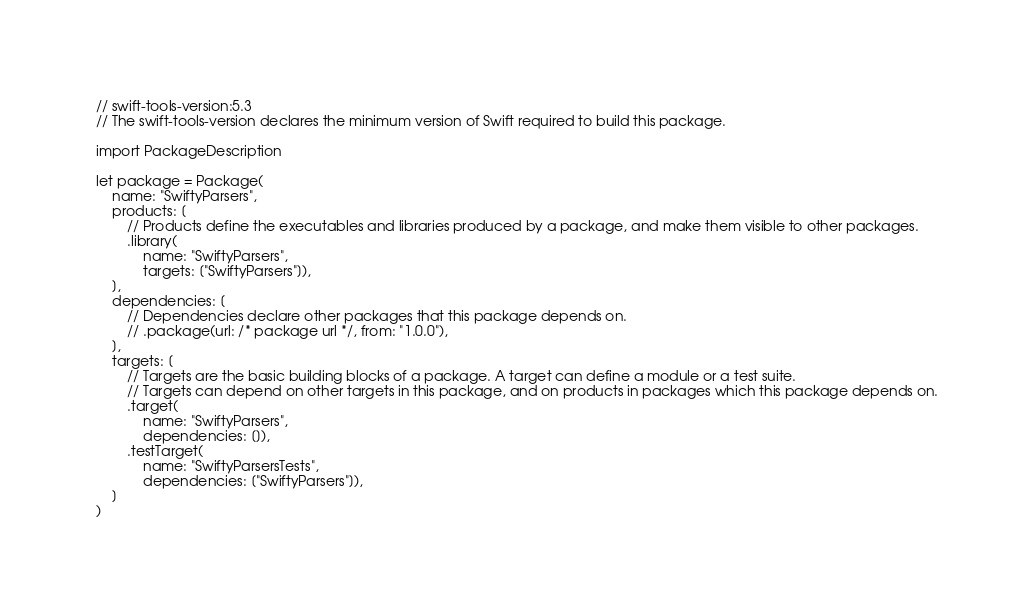<code> <loc_0><loc_0><loc_500><loc_500><_Swift_>// swift-tools-version:5.3
// The swift-tools-version declares the minimum version of Swift required to build this package.

import PackageDescription

let package = Package(
    name: "SwiftyParsers",
    products: [
        // Products define the executables and libraries produced by a package, and make them visible to other packages.
        .library(
            name: "SwiftyParsers",
            targets: ["SwiftyParsers"]),
    ],
    dependencies: [
        // Dependencies declare other packages that this package depends on.
        // .package(url: /* package url */, from: "1.0.0"),
    ],
    targets: [
        // Targets are the basic building blocks of a package. A target can define a module or a test suite.
        // Targets can depend on other targets in this package, and on products in packages which this package depends on.
        .target(
            name: "SwiftyParsers",
            dependencies: []),
        .testTarget(
            name: "SwiftyParsersTests",
            dependencies: ["SwiftyParsers"]),
    ]
)
</code> 